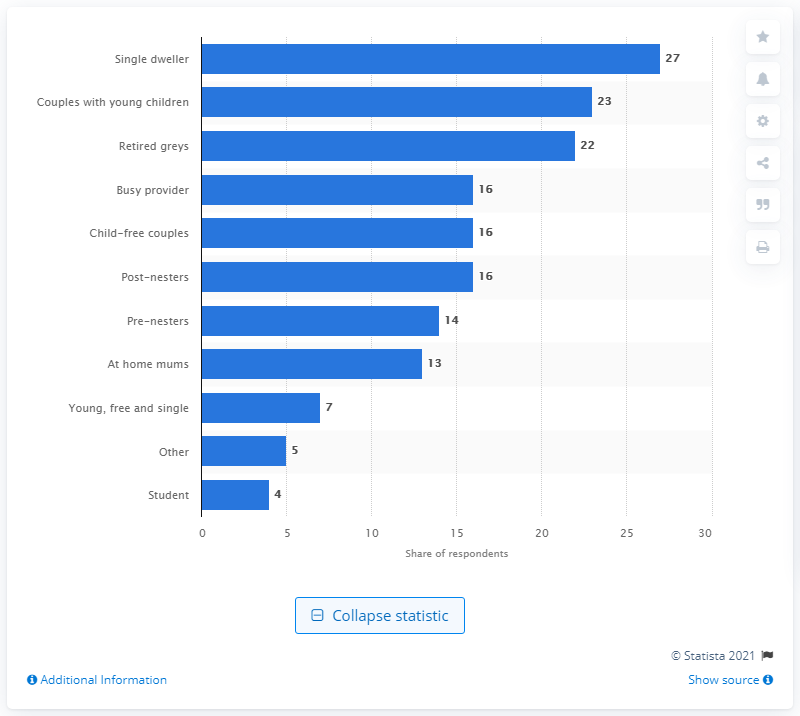Give some essential details in this illustration. In the UK, a significant percentage of shoppers are couples with young children, with 23% fitting this demographic. According to a recent survey, 27% of UK shoppers are single dwellers. 